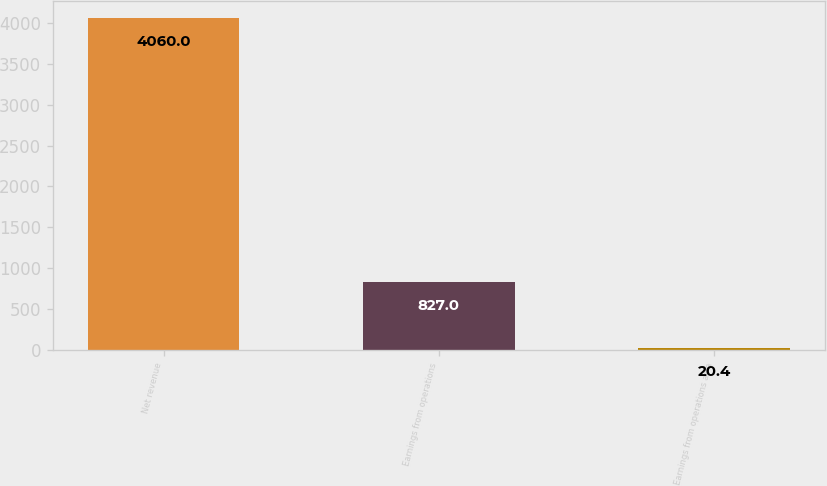Convert chart to OTSL. <chart><loc_0><loc_0><loc_500><loc_500><bar_chart><fcel>Net revenue<fcel>Earnings from operations<fcel>Earnings from operations as a<nl><fcel>4060<fcel>827<fcel>20.4<nl></chart> 